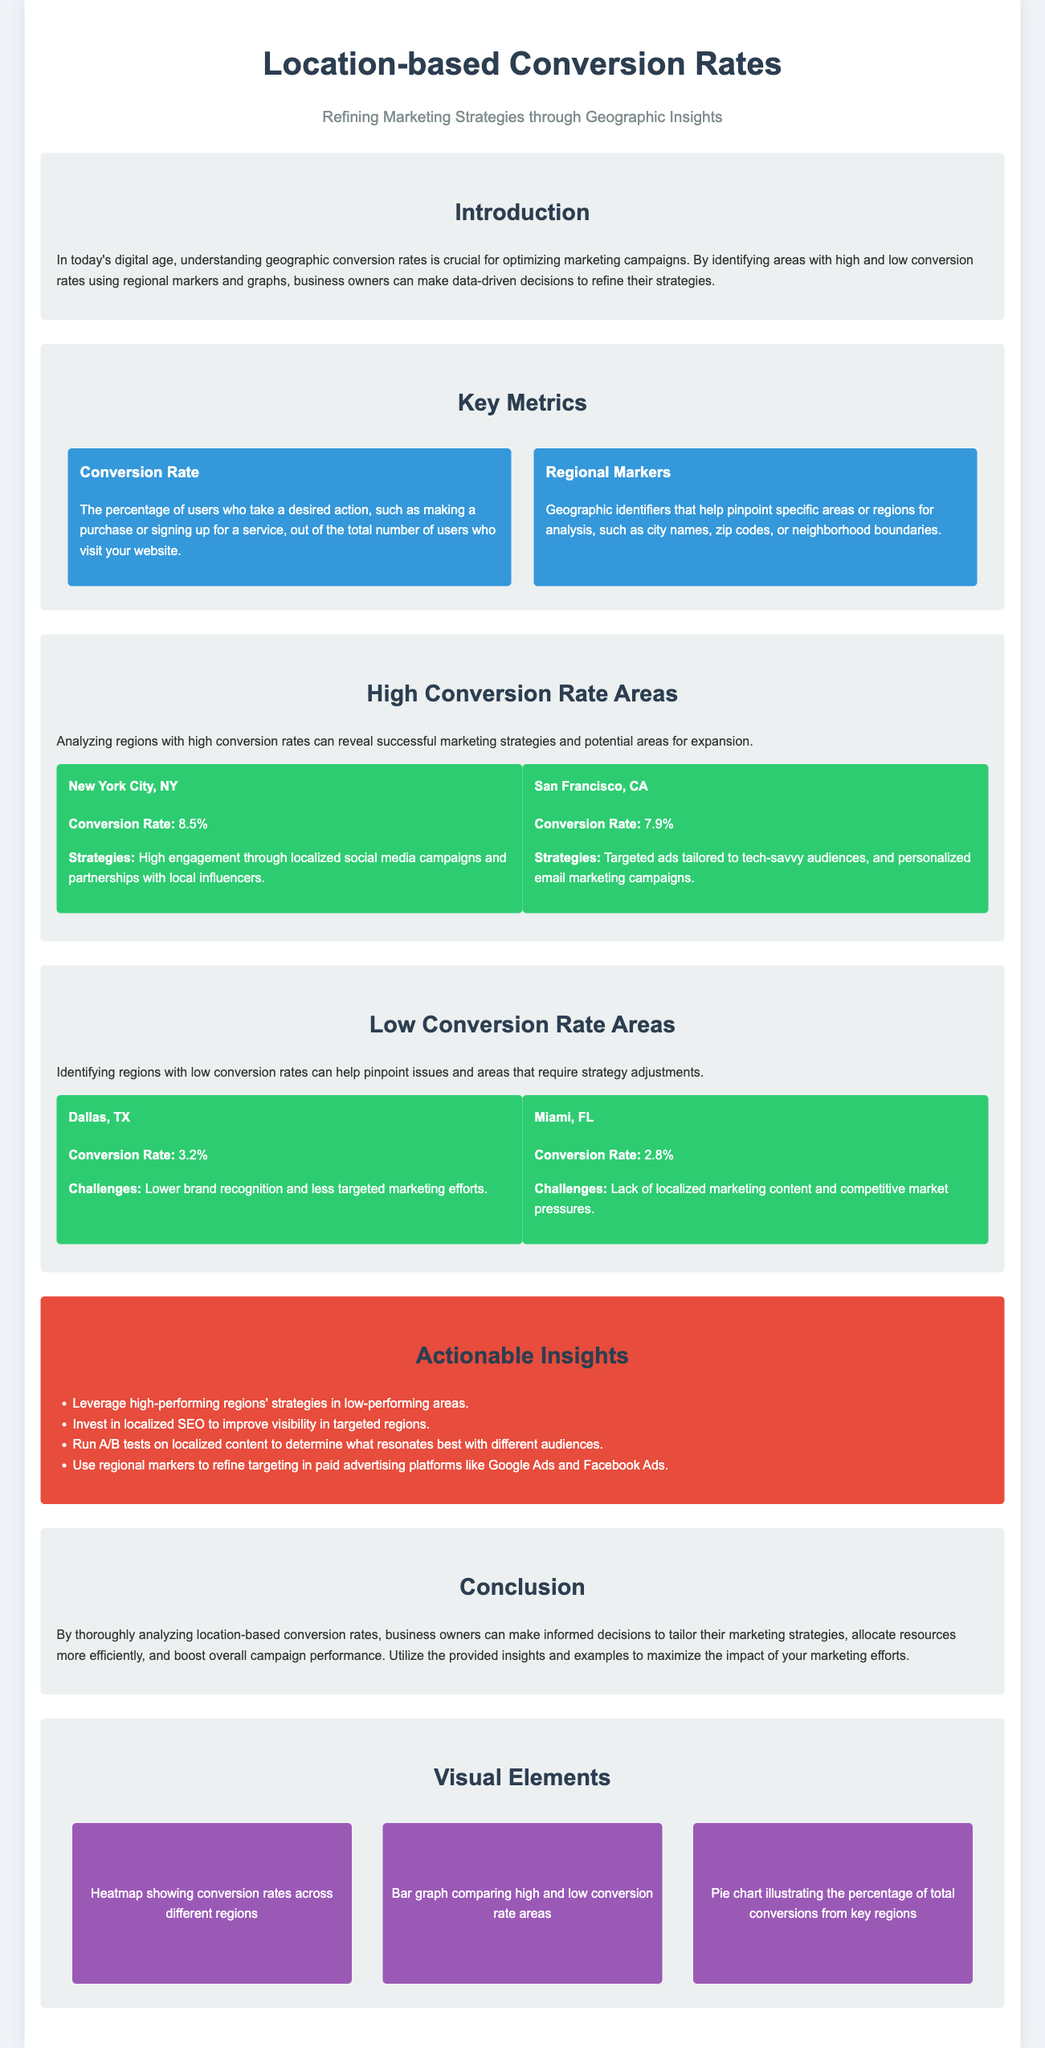What is the conversion rate for New York City? The document states that the conversion rate for New York City is 8.5%.
Answer: 8.5% What strategies contributed to the high conversion rate in San Francisco? The document mentions that targeted ads tailored to tech-savvy audiences and personalized email marketing campaigns contributed to San Francisco's high conversion rate.
Answer: Targeted ads and personalized email marketing What is the conversion rate for Miami? The document indicates that Miami has a conversion rate of 2.8%.
Answer: 2.8% Which city has the lowest conversion rate listed? The document presents Miami, FL, as having the lowest conversion rate at 2.8%.
Answer: Miami, FL What are some challenges faced in Dallas? The document notes lower brand recognition and less targeted marketing efforts as challenges in Dallas.
Answer: Lower brand recognition and less targeted marketing efforts What is one actionable insight proposed in the infographic? The document suggests leveraging high-performing regions' strategies in low-performing areas as one actionable insight.
Answer: Leverage high-performing regions' strategies What type of visual element is mentioned for illustrating conversion rates? The document lists a heatmap showing conversion rates across different regions as a visual element.
Answer: Heatmap What two regions are analyzed for high conversion rates? The document highlights New York City, NY, and San Francisco, CA as the regions analyzed for high conversion rates.
Answer: New York City, NY and San Francisco, CA What is the subtitle of the infographic? The document specifies "Refining Marketing Strategies through Geographic Insights" as the subtitle.
Answer: Refining Marketing Strategies through Geographic Insights 